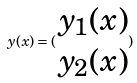Convert formula to latex. <formula><loc_0><loc_0><loc_500><loc_500>y ( x ) = ( \begin{matrix} y _ { 1 } ( x ) \\ y _ { 2 } ( x ) \end{matrix} )</formula> 